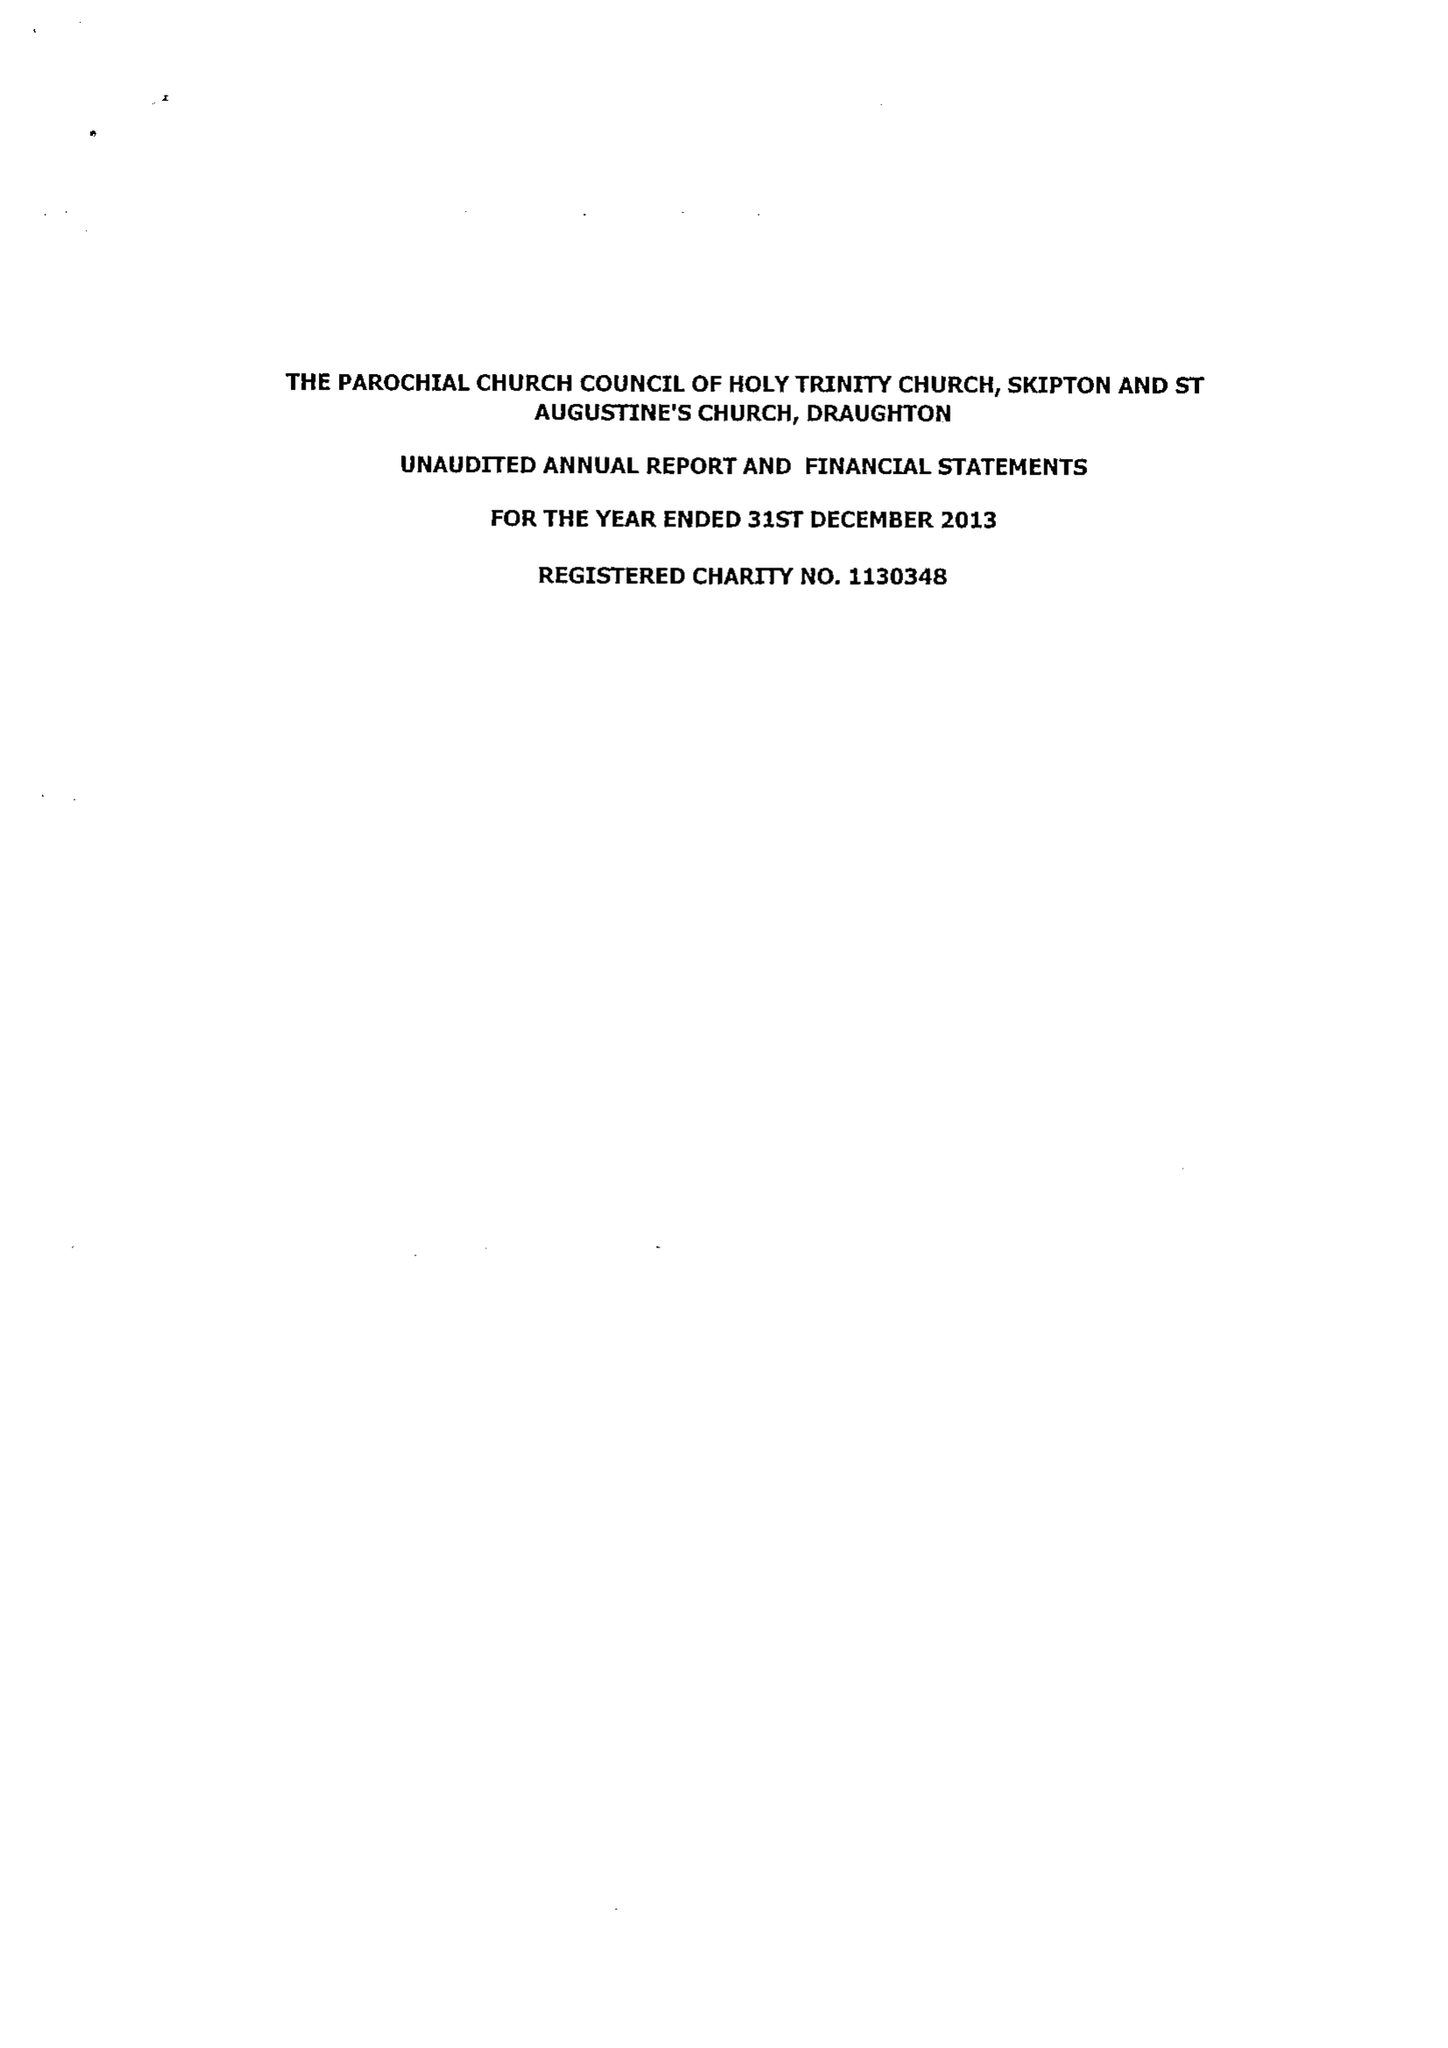What is the value for the report_date?
Answer the question using a single word or phrase. 2013-12-31 